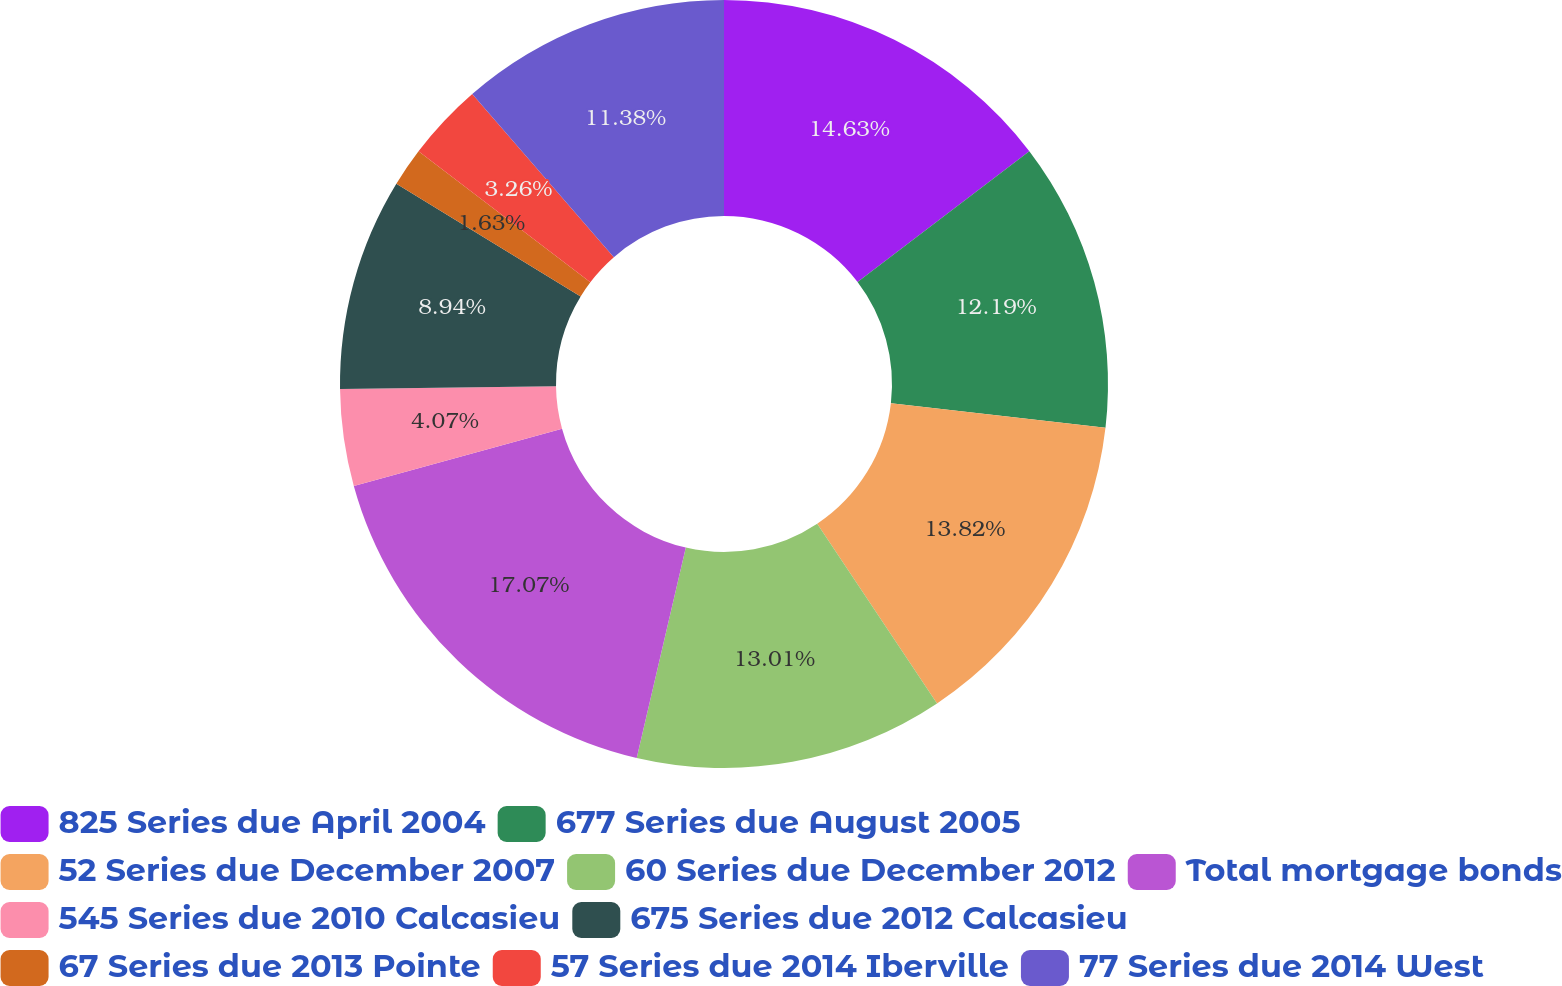Convert chart. <chart><loc_0><loc_0><loc_500><loc_500><pie_chart><fcel>825 Series due April 2004<fcel>677 Series due August 2005<fcel>52 Series due December 2007<fcel>60 Series due December 2012<fcel>Total mortgage bonds<fcel>545 Series due 2010 Calcasieu<fcel>675 Series due 2012 Calcasieu<fcel>67 Series due 2013 Pointe<fcel>57 Series due 2014 Iberville<fcel>77 Series due 2014 West<nl><fcel>14.63%<fcel>12.19%<fcel>13.82%<fcel>13.01%<fcel>17.07%<fcel>4.07%<fcel>8.94%<fcel>1.63%<fcel>3.26%<fcel>11.38%<nl></chart> 